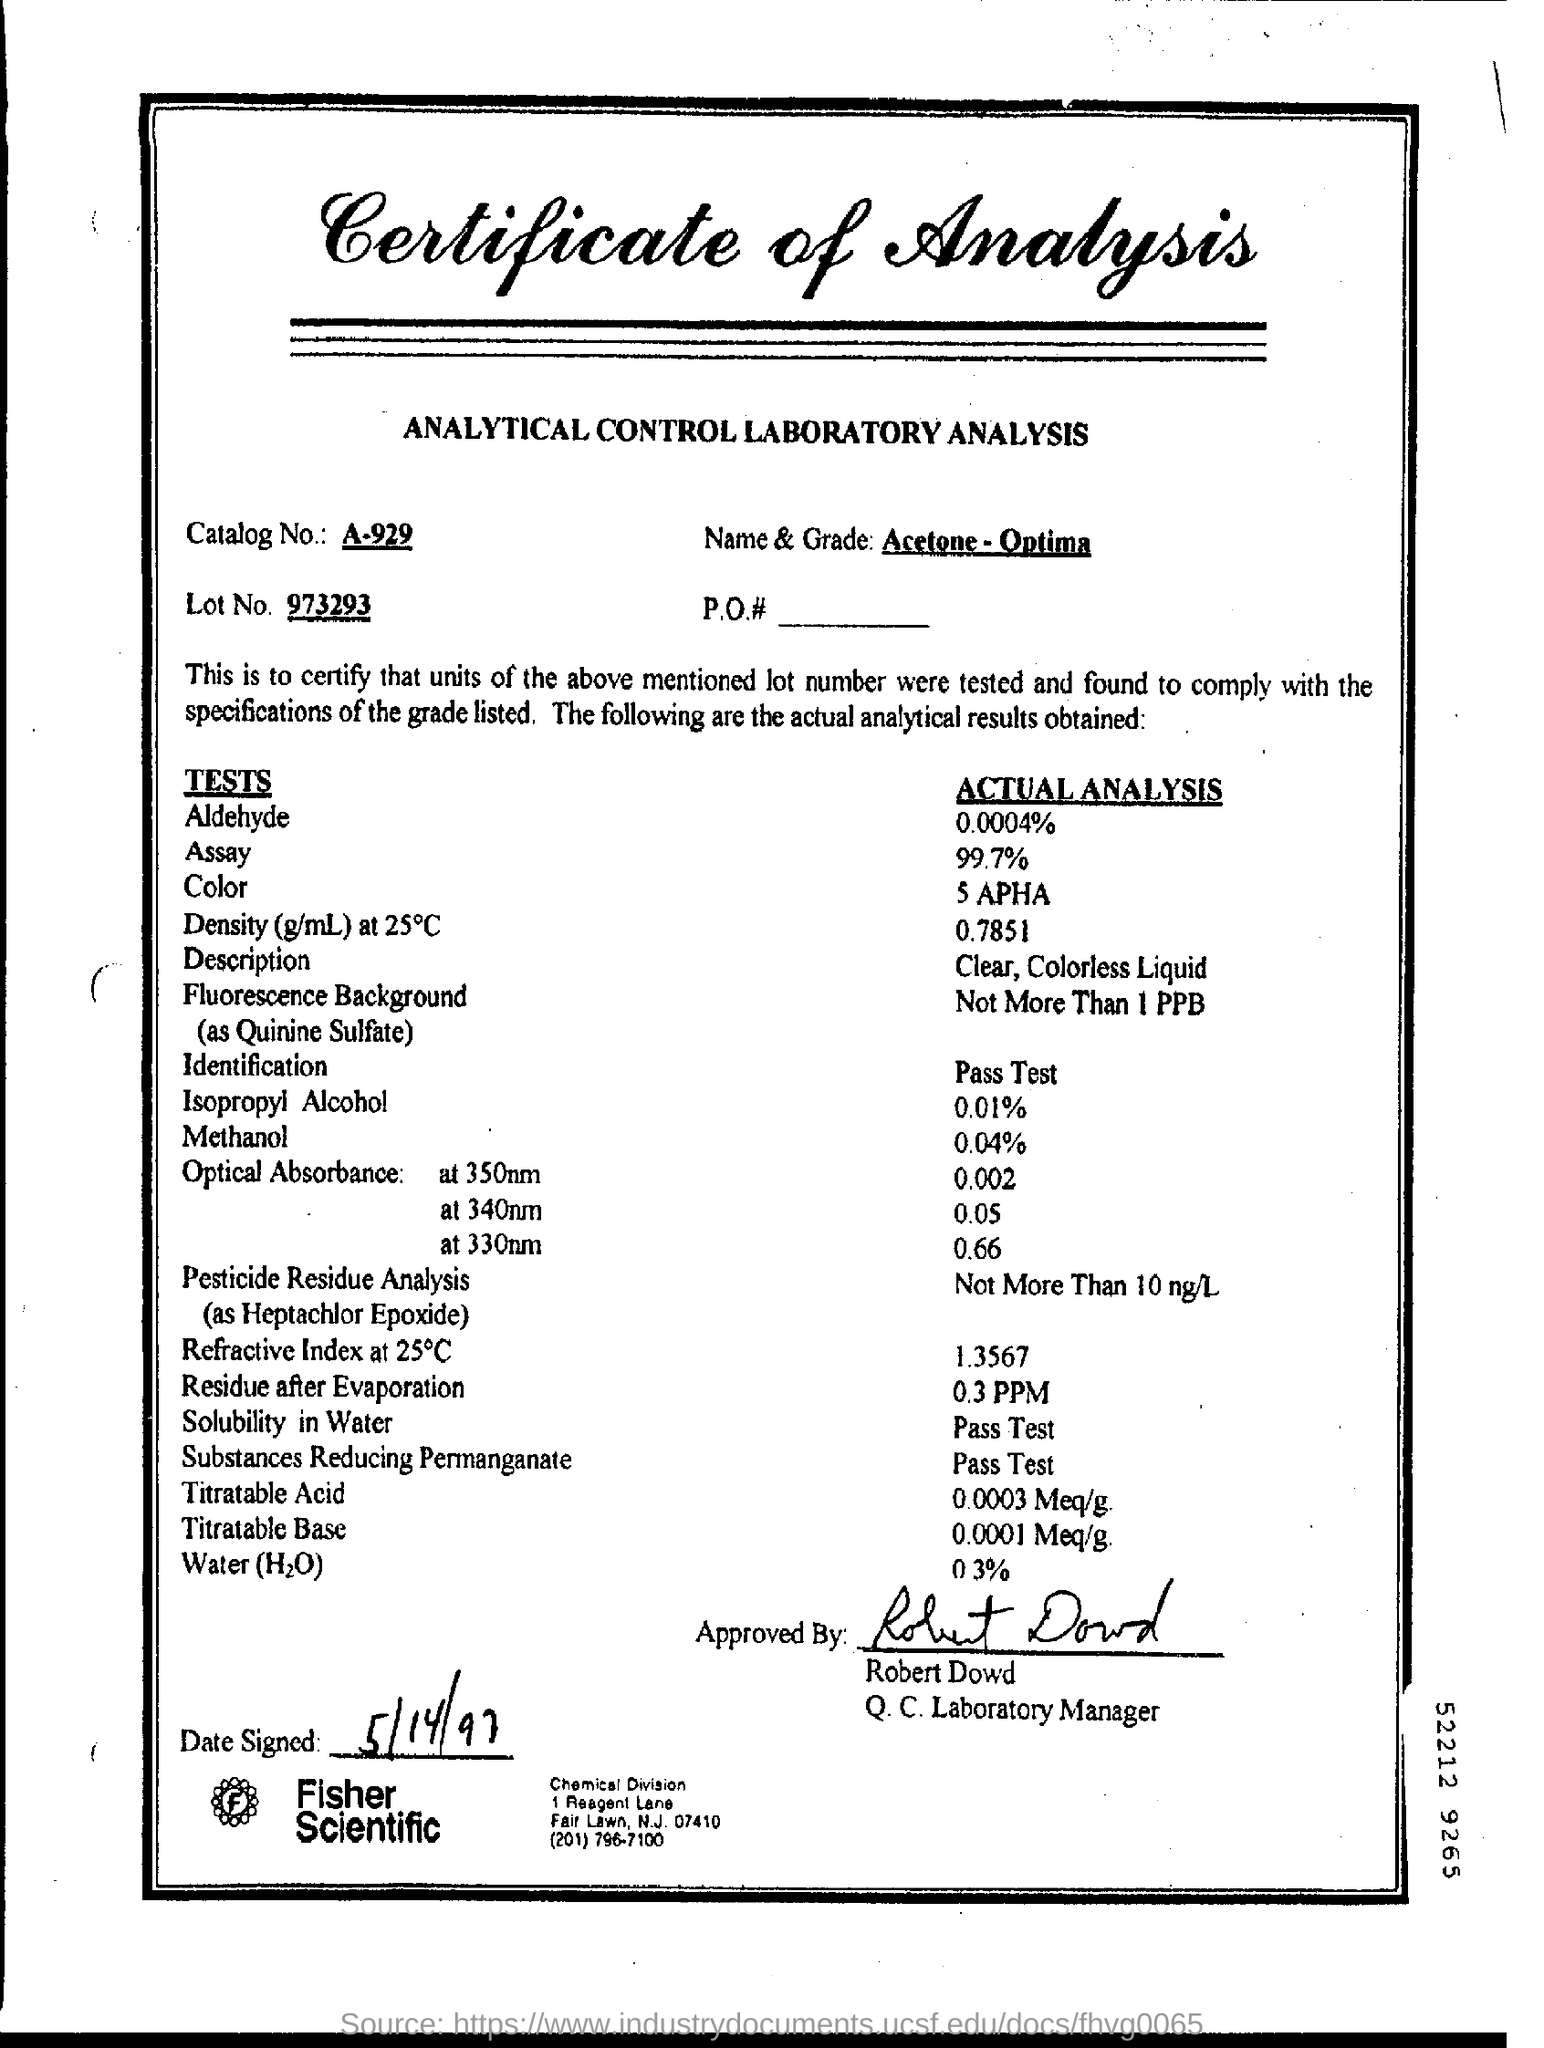Specify some key components in this picture. It has been approved by Robert Dowd. The actual analysis for methanol is 0.04%. The substance identified as "Acetone - Optima" is a type of solvent with the chemical name and grade unknown. The actual analysis for aldehyde is 0.0004%. The date "5/14/97" was signed on May 14th, 1997. 